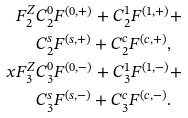Convert formula to latex. <formula><loc_0><loc_0><loc_500><loc_500>F _ { 2 } ^ { Z } & C _ { 2 } ^ { 0 } F ^ { ( 0 , + ) } + C _ { 2 } ^ { 1 } F ^ { ( 1 , + ) } + \\ & C _ { 2 } ^ { s } F ^ { ( s , + ) } + C _ { 2 } ^ { c } F ^ { ( c , + ) } , \\ x F _ { 3 } ^ { Z } & C _ { 3 } ^ { 0 } F ^ { ( 0 , - ) } + C _ { 3 } ^ { 1 } F ^ { ( 1 , - ) } + \\ & C _ { 3 } ^ { s } F ^ { ( s , - ) } + C _ { 3 } ^ { c } F ^ { ( c , - ) } .</formula> 